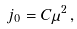Convert formula to latex. <formula><loc_0><loc_0><loc_500><loc_500>j _ { 0 } = C \mu ^ { 2 } \, ,</formula> 